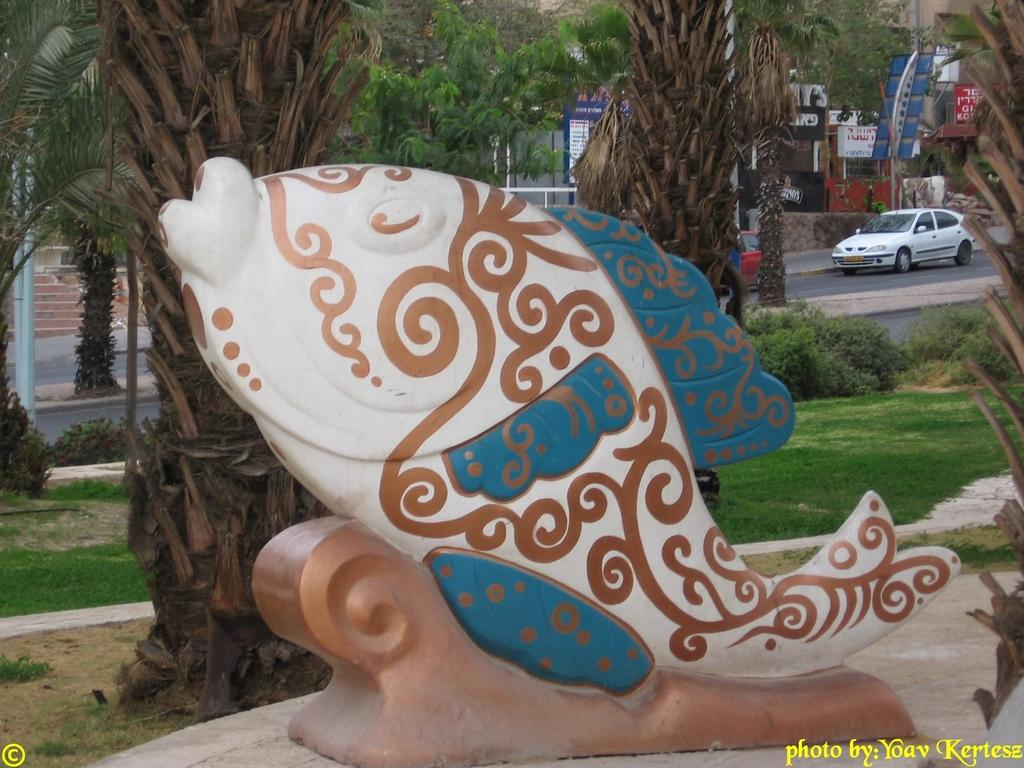What is the main object in the foreground of the image? There is a toy fish in the foreground of the image. What can be seen in the background of the image? There are trees, buildings, a car, poles, and a road in the background of the image. How many types of structures are visible in the background? There are two types of structures visible in the background: buildings and poles. What type of bomb is hidden in the toy fish in the image? There is no bomb present in the image, and the toy fish does not contain any hidden objects. What color is the stocking on the car in the image? There is no stocking present on the car in the image; it is a regular car without any additional accessories. 